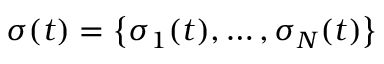<formula> <loc_0><loc_0><loc_500><loc_500>\sigma ( t ) = \left \{ \sigma _ { 1 } ( t ) , \dots , \sigma _ { N } ( t ) \right \}</formula> 